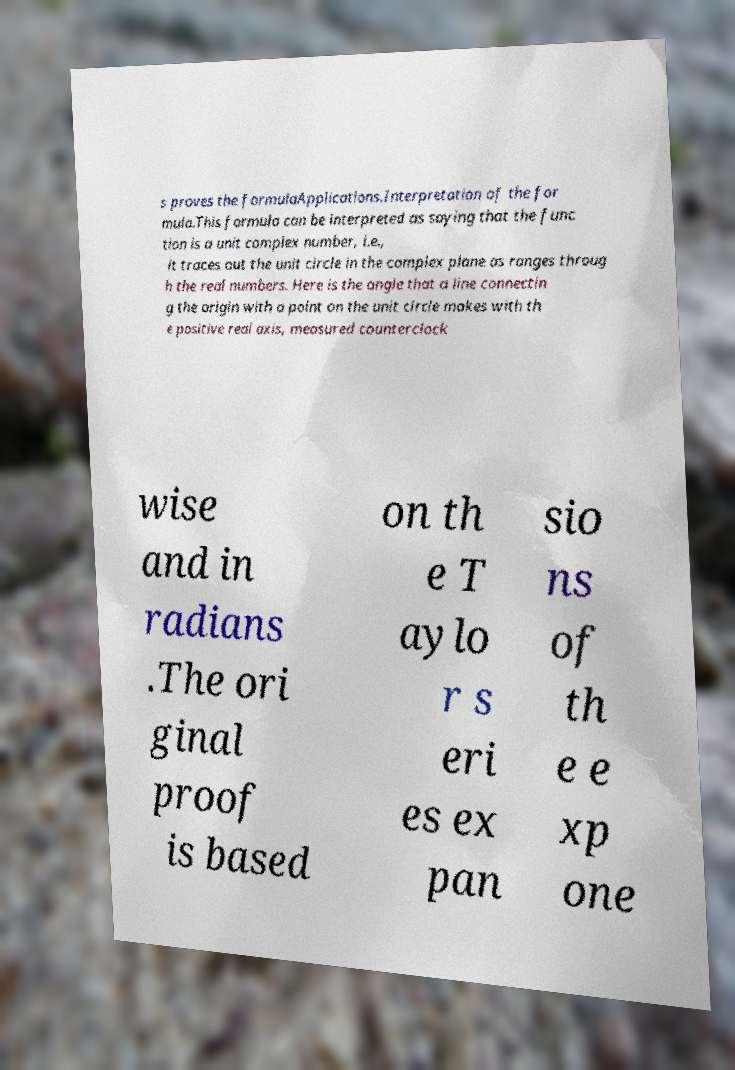Please identify and transcribe the text found in this image. s proves the formulaApplications.Interpretation of the for mula.This formula can be interpreted as saying that the func tion is a unit complex number, i.e., it traces out the unit circle in the complex plane as ranges throug h the real numbers. Here is the angle that a line connectin g the origin with a point on the unit circle makes with th e positive real axis, measured counterclock wise and in radians .The ori ginal proof is based on th e T aylo r s eri es ex pan sio ns of th e e xp one 